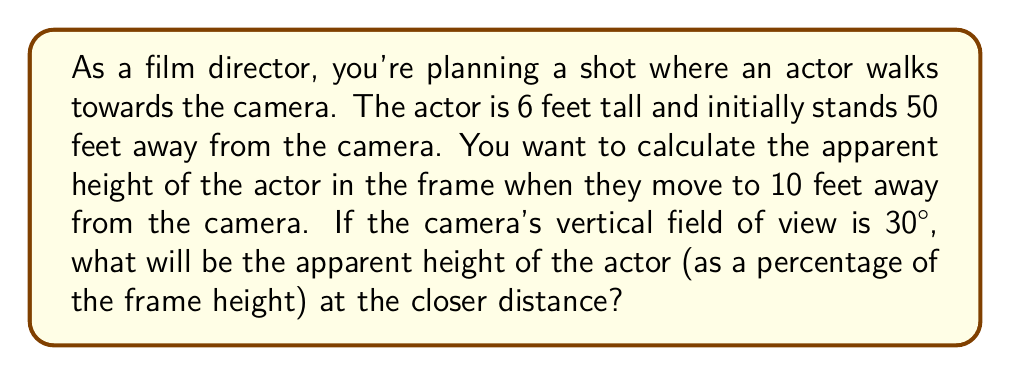What is the answer to this math problem? To solve this problem, we'll use the concept of angular size in trigonometry. The apparent size of an object is related to its actual size and distance from the viewer (or camera).

1. First, let's calculate the angular size of the actor at the initial position:
   $$ \theta_1 = 2 \arctan(\frac{h}{2d_1}) $$
   Where $h$ is the height of the actor (6 feet) and $d_1$ is the initial distance (50 feet).
   $$ \theta_1 = 2 \arctan(\frac{6}{2 \cdot 50}) \approx 0.1197 \text{ radians} \approx 6.86° $$

2. Now, let's calculate the angular size at the closer position:
   $$ \theta_2 = 2 \arctan(\frac{h}{2d_2}) $$
   Where $d_2$ is the new distance (10 feet).
   $$ \theta_2 = 2 \arctan(\frac{6}{2 \cdot 10}) \approx 0.5830 \text{ radians} \approx 33.40° $$

3. The camera's vertical field of view (FOV) is 30°. To find the apparent height as a percentage of the frame, we divide the actor's angular size by the FOV:
   $$ \text{Apparent Height (%)} = \frac{\theta_2}{\text{FOV}} \cdot 100\% $$
   $$ \text{Apparent Height (%)} = \frac{33.40°}{30°} \cdot 100\% \approx 111.33\% $$

This means the actor will appear taller than the frame at the closer distance.
Answer: The apparent height of the actor at 10 feet from the camera will be approximately 111.33% of the frame height. 